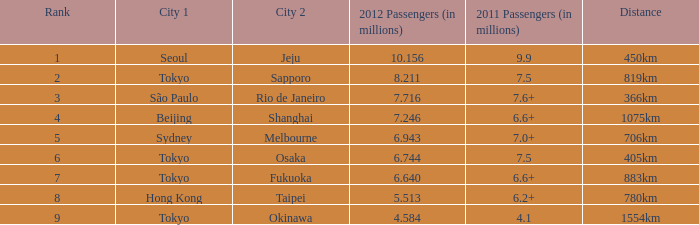On the route with a distance of 1075km and more than 6.6 million passengers in 2011, which city is listed first? Beijing. 